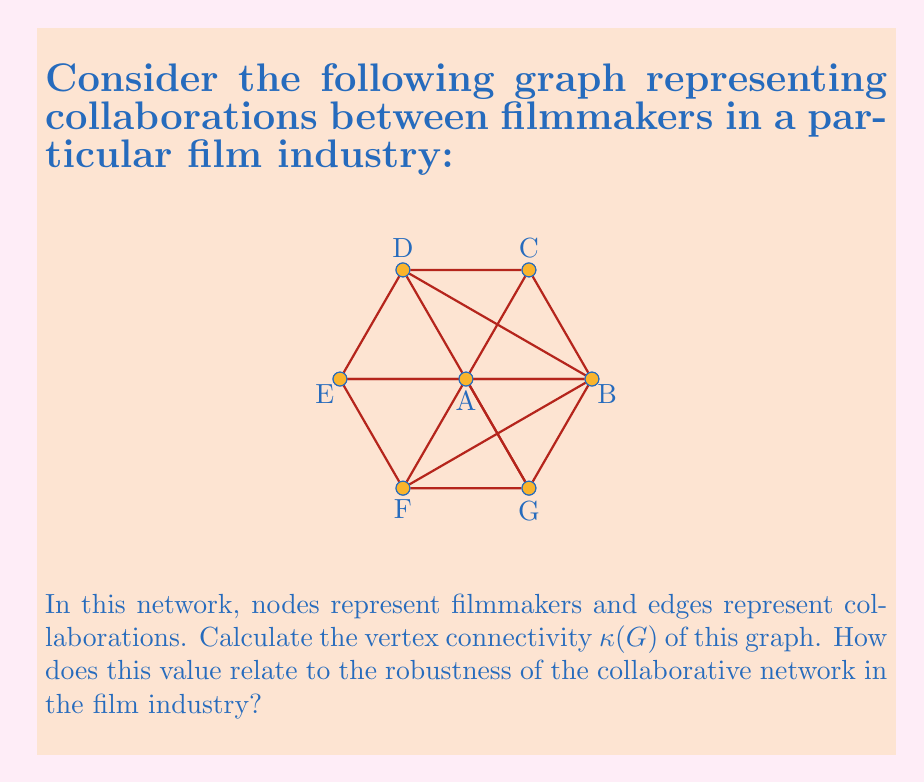Give your solution to this math problem. To solve this problem, we'll follow these steps:

1) First, recall that the vertex connectivity $\kappa(G)$ of a graph G is the minimum number of vertices whose removal results in a disconnected or trivial graph.

2) Observe that the graph is complete (fully connected) except for the edge between nodes B and E.

3) To disconnect this graph, we need to remove all vertices except B and E. This would leave B and E isolated, creating a disconnected graph.

4) Count the number of vertices we need to remove:
   Total vertices: 7
   Vertices to leave: 2 (B and E)
   Vertices to remove: 7 - 2 = 5

5) Therefore, $\kappa(G) = 5$

6) Interpretation in the context of the film industry:
   - A high vertex connectivity (5 out of 7 possible) indicates a robust collaborative network.
   - It would take removing 5 filmmakers from the network to completely disrupt the collaboration structure.
   - This suggests a highly interconnected industry where most filmmakers have worked with most others.
   - Such a network structure facilitates knowledge sharing, creative exchange, and resilience to the loss of individual members.

7) However, note that while robust, the network is not maximally connected (which would have $\kappa(G) = 6$ for a 7-vertex graph). This single "missing" collaboration (between B and E) could represent an opportunity for new creative partnerships or a historical/cultural divide in the industry.
Answer: $\kappa(G) = 5$ 